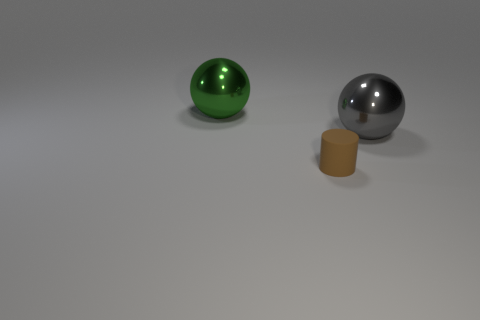The tiny cylinder is what color?
Your response must be concise. Brown. How many metallic objects are either tiny things or large red spheres?
Provide a short and direct response. 0. The other big thing that is the same shape as the gray object is what color?
Offer a very short reply. Green. Are any tiny purple rubber cylinders visible?
Provide a short and direct response. No. Is the material of the big thing in front of the big green shiny sphere the same as the thing in front of the large gray object?
Provide a succinct answer. No. What number of objects are gray objects that are behind the matte cylinder or things on the left side of the large gray sphere?
Provide a succinct answer. 3. There is a object that is both behind the small brown matte cylinder and in front of the big green sphere; what shape is it?
Your response must be concise. Sphere. There is a metal sphere that is the same size as the green shiny thing; what color is it?
Give a very brief answer. Gray. There is a sphere that is left of the tiny brown rubber object; is its size the same as the shiny ball right of the large green metallic sphere?
Keep it short and to the point. Yes. What is the object that is both in front of the big green thing and to the left of the big gray object made of?
Your answer should be very brief. Rubber. 